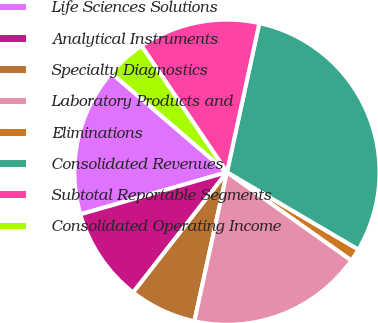<chart> <loc_0><loc_0><loc_500><loc_500><pie_chart><fcel>Life Sciences Solutions<fcel>Analytical Instruments<fcel>Specialty Diagnostics<fcel>Laboratory Products and<fcel>Eliminations<fcel>Consolidated Revenues<fcel>Subtotal Reportable Segments<fcel>Consolidated Operating Income<nl><fcel>15.74%<fcel>10.0%<fcel>7.12%<fcel>18.61%<fcel>1.35%<fcel>30.06%<fcel>12.87%<fcel>4.25%<nl></chart> 